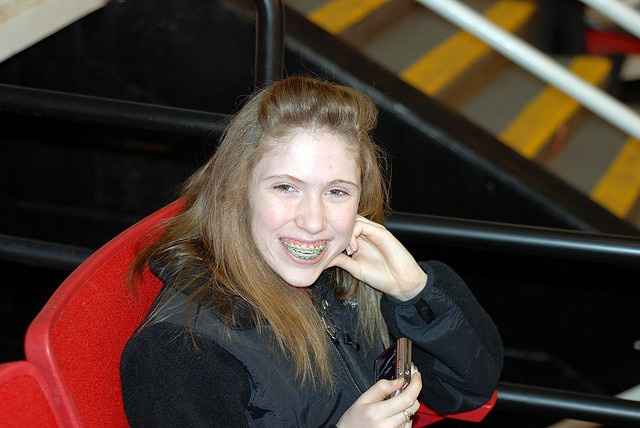Describe the objects in this image and their specific colors. I can see people in darkgray, black, lightgray, and gray tones, chair in darkgray, brown, red, and black tones, chair in darkgray, brown, and red tones, and cell phone in darkgray, black, gray, and maroon tones in this image. 